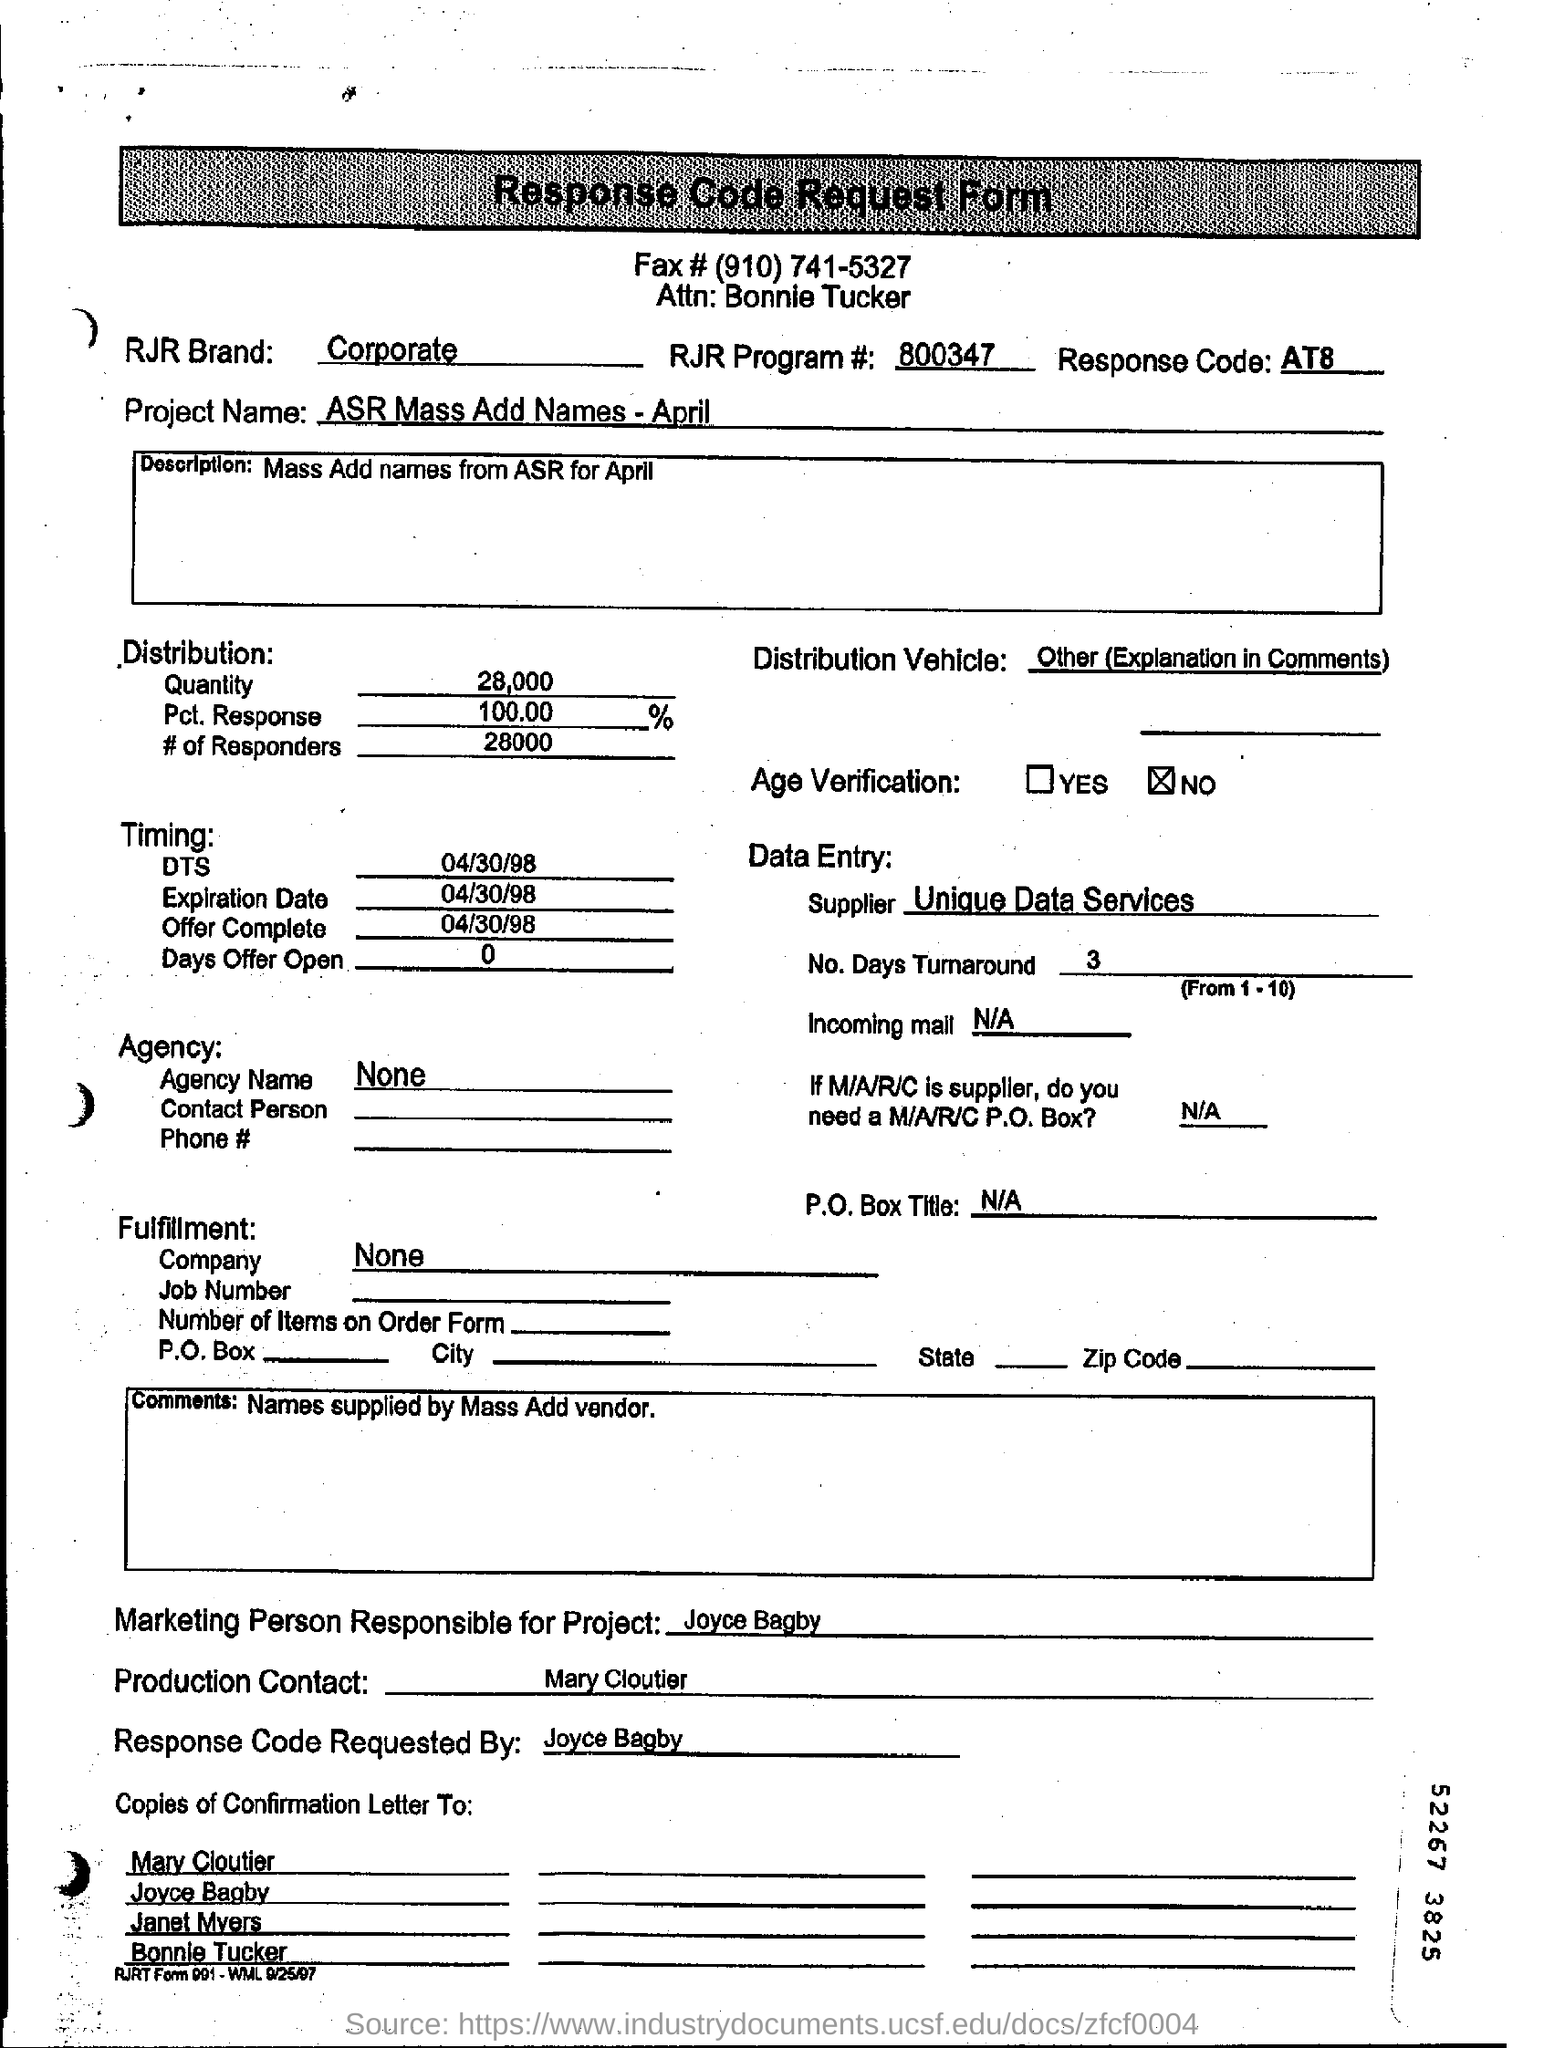Draw attention to some important aspects in this diagram. The RJR Program number is 800347. The Production contact is Mary Cloutier. The response code mentioned is AT8.. The quantity of distribution is 28,000. The individual responsible for Project is Joyce Bagby, a marketing professional. 